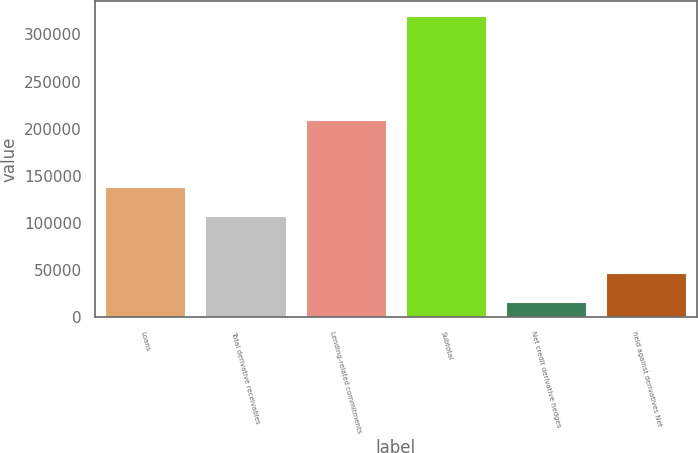<chart> <loc_0><loc_0><loc_500><loc_500><bar_chart><fcel>Loans<fcel>Total derivative receivables<fcel>Lending-related commitments<fcel>Subtotal<fcel>Net credit derivative hedges<fcel>held against derivatives Net<nl><fcel>137729<fcel>107401<fcel>209299<fcel>319701<fcel>16415<fcel>46743.6<nl></chart> 